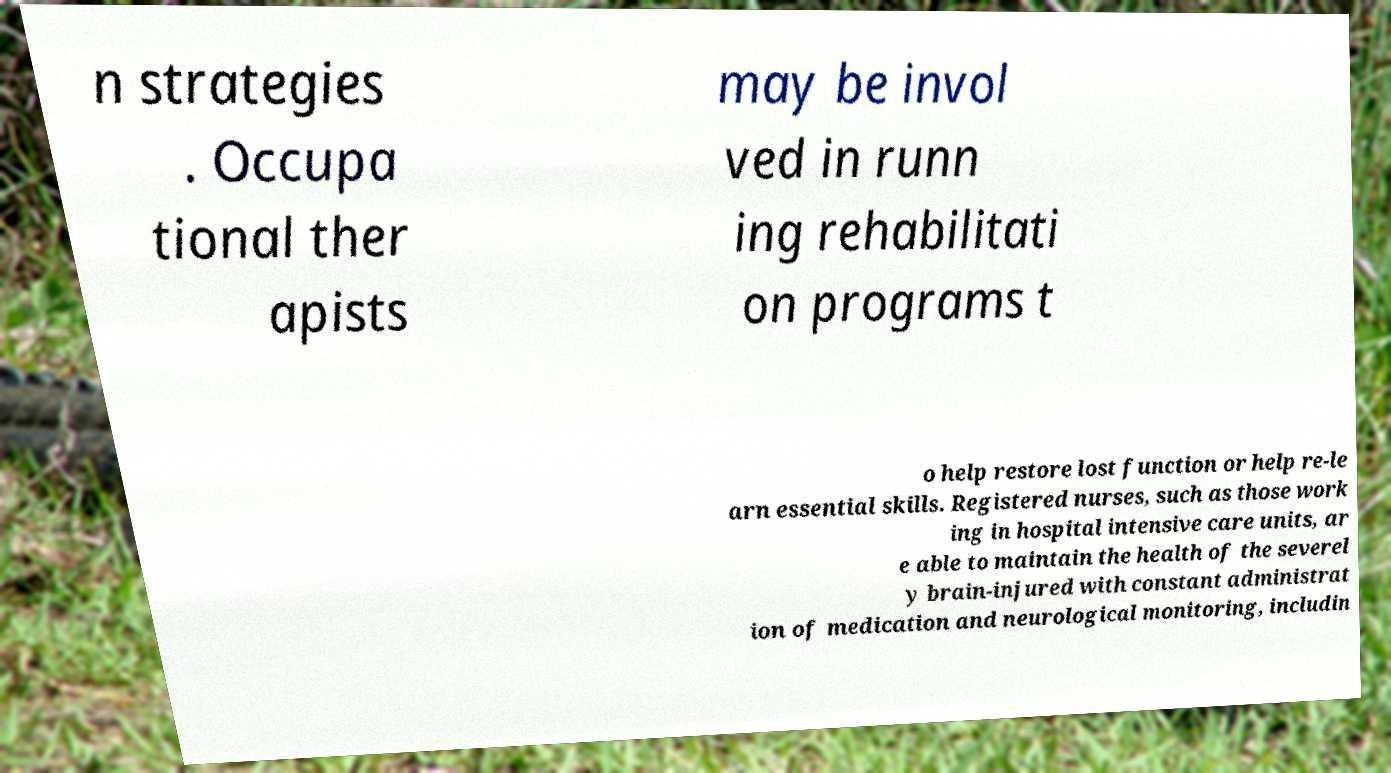Can you accurately transcribe the text from the provided image for me? n strategies . Occupa tional ther apists may be invol ved in runn ing rehabilitati on programs t o help restore lost function or help re-le arn essential skills. Registered nurses, such as those work ing in hospital intensive care units, ar e able to maintain the health of the severel y brain-injured with constant administrat ion of medication and neurological monitoring, includin 